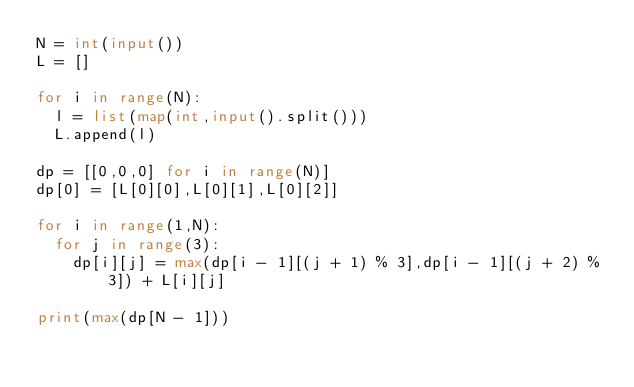<code> <loc_0><loc_0><loc_500><loc_500><_Python_>N = int(input())
L = []

for i in range(N):
  l = list(map(int,input().split()))
  L.append(l)
  
dp = [[0,0,0] for i in range(N)]
dp[0] = [L[0][0],L[0][1],L[0][2]]

for i in range(1,N):
  for j in range(3):
    dp[i][j] = max(dp[i - 1][(j + 1) % 3],dp[i - 1][(j + 2) % 3]) + L[i][j]
    
print(max(dp[N - 1]))</code> 